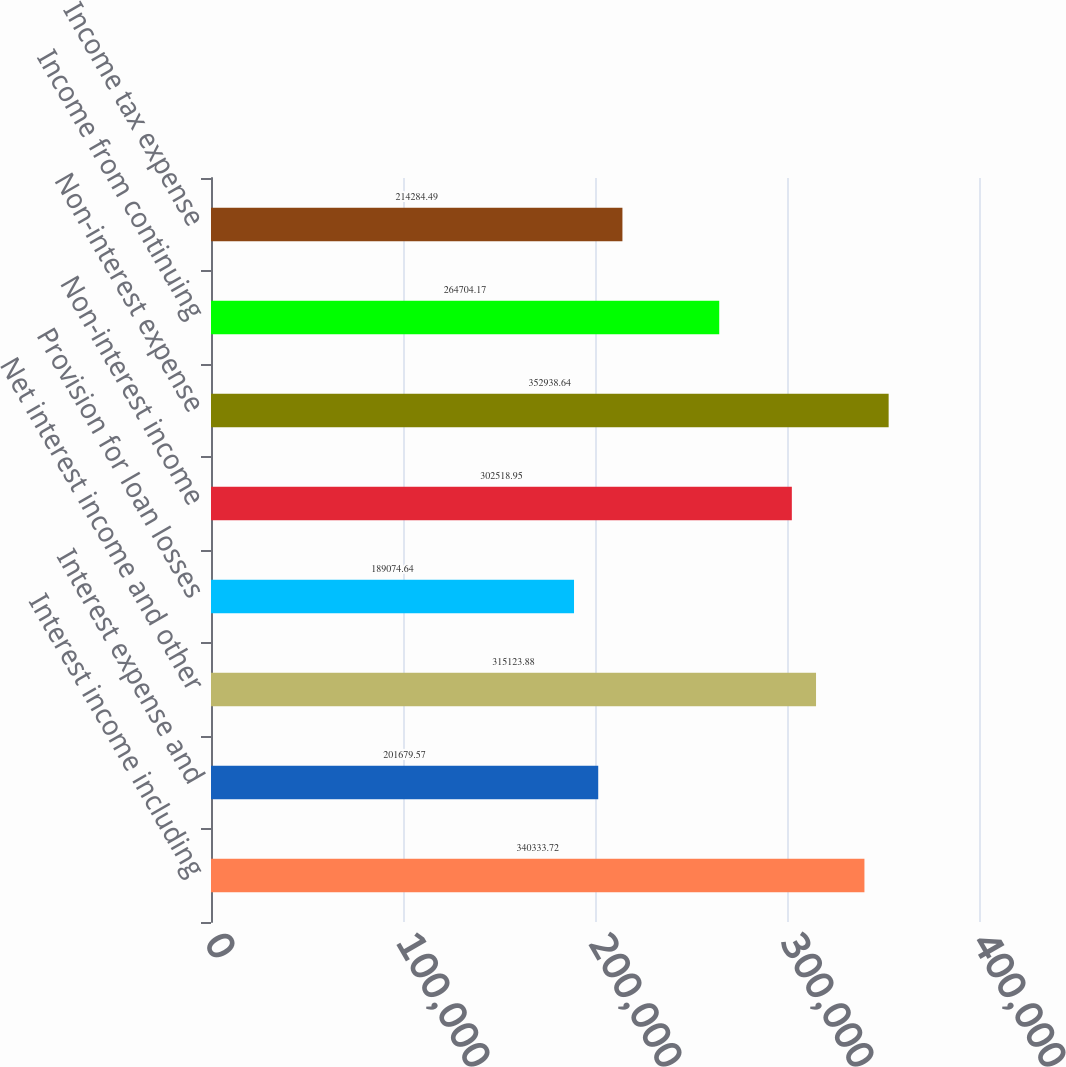Convert chart to OTSL. <chart><loc_0><loc_0><loc_500><loc_500><bar_chart><fcel>Interest income including<fcel>Interest expense and<fcel>Net interest income and other<fcel>Provision for loan losses<fcel>Non-interest income<fcel>Non-interest expense<fcel>Income from continuing<fcel>Income tax expense<nl><fcel>340334<fcel>201680<fcel>315124<fcel>189075<fcel>302519<fcel>352939<fcel>264704<fcel>214284<nl></chart> 